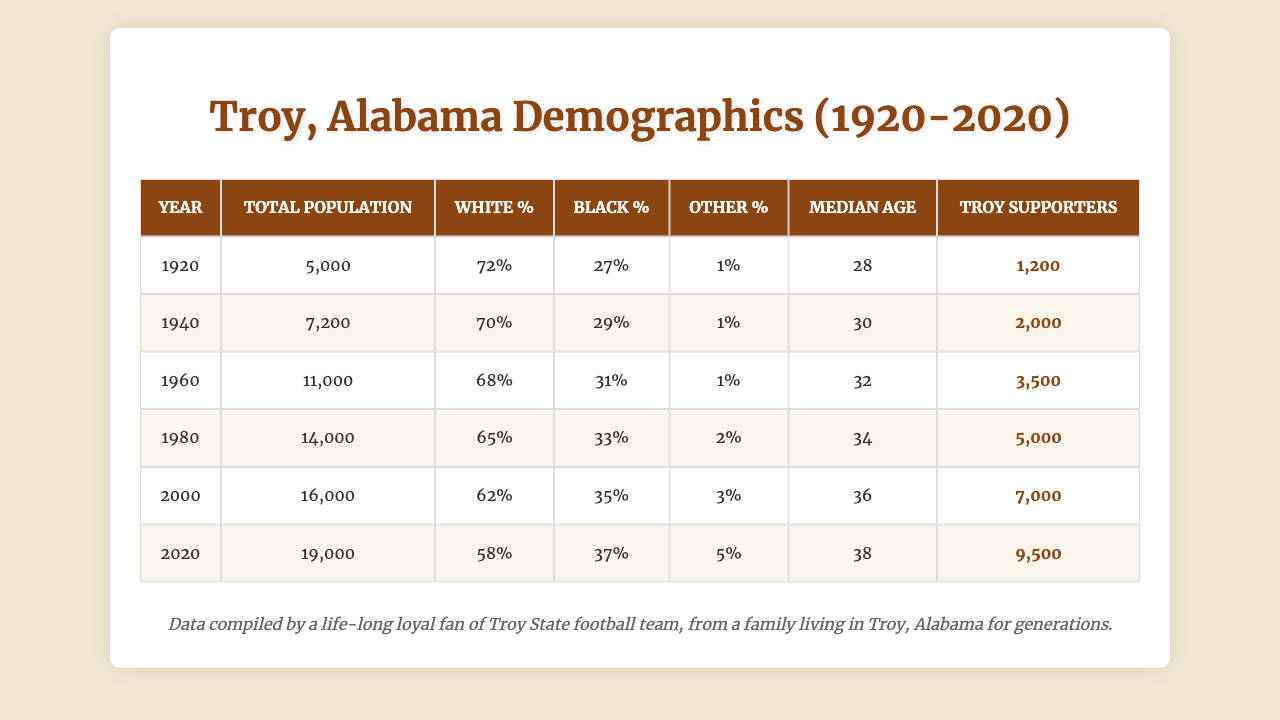What was the total population of Troy, Alabama in 2000? Looking at the table, the total population in the year 2000 is listed as 16,000.
Answer: 16,000 What percentage of the population identified as white in 1980? From the table, the white percentage in 1980 is given as 65%.
Answer: 65% In which year was the median age the highest? By checking the median age values in the years listed, 2020 has the highest median age at 38 years.
Answer: 2020 How many Troy supporters were there in 1960? The table shows that in 1960, there were 3,500 Troy supporters.
Answer: 3,500 What was the change in the total population from 1920 to 2020? The total population in 1920 was 5,000, and in 2020 it was 19,000. The change is calculated as 19,000 - 5,000 = 14,000.
Answer: 14,000 Was the percentage of Black residents in Troy, Alabama higher in 1940 or 1980? The table states that the Black percentage in 1940 was 29%, and in 1980 it was 33%. Since 33% is greater than 29%, the answer is 1980.
Answer: 1980 What is the average percentage of white residents from 1920 to 2020? The white percentages are 72, 70, 68, 65, 62, and 58. Adding these gives 72 + 70 + 68 + 65 + 62 + 58 = 405, and dividing by 6 gives 405 / 6 = 67.5%.
Answer: 67.5% In what year did the population first exceed 10,000? Referring to the population figures, the first occurrence of a population over 10,000 was in 1960, which recorded 11,000.
Answer: 1960 What was the percentage of "other" residents in 2000? The table indicates that 3% of the population identified as "other" in 2000.
Answer: 3% How many total Troy supporters were there in 1920 compared to 2020? In 1920, there were 1,200 Troy supporters and in 2020 there were 9,500. The difference is calculated as 9,500 - 1,200 = 8,300.
Answer: 8,300 